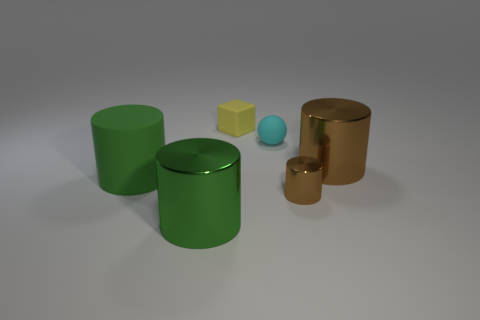Add 1 matte spheres. How many objects exist? 7 Subtract all blocks. How many objects are left? 5 Add 4 green objects. How many green objects are left? 6 Add 6 blocks. How many blocks exist? 7 Subtract 1 yellow cubes. How many objects are left? 5 Subtract all small cyan matte spheres. Subtract all tiny gray cylinders. How many objects are left? 5 